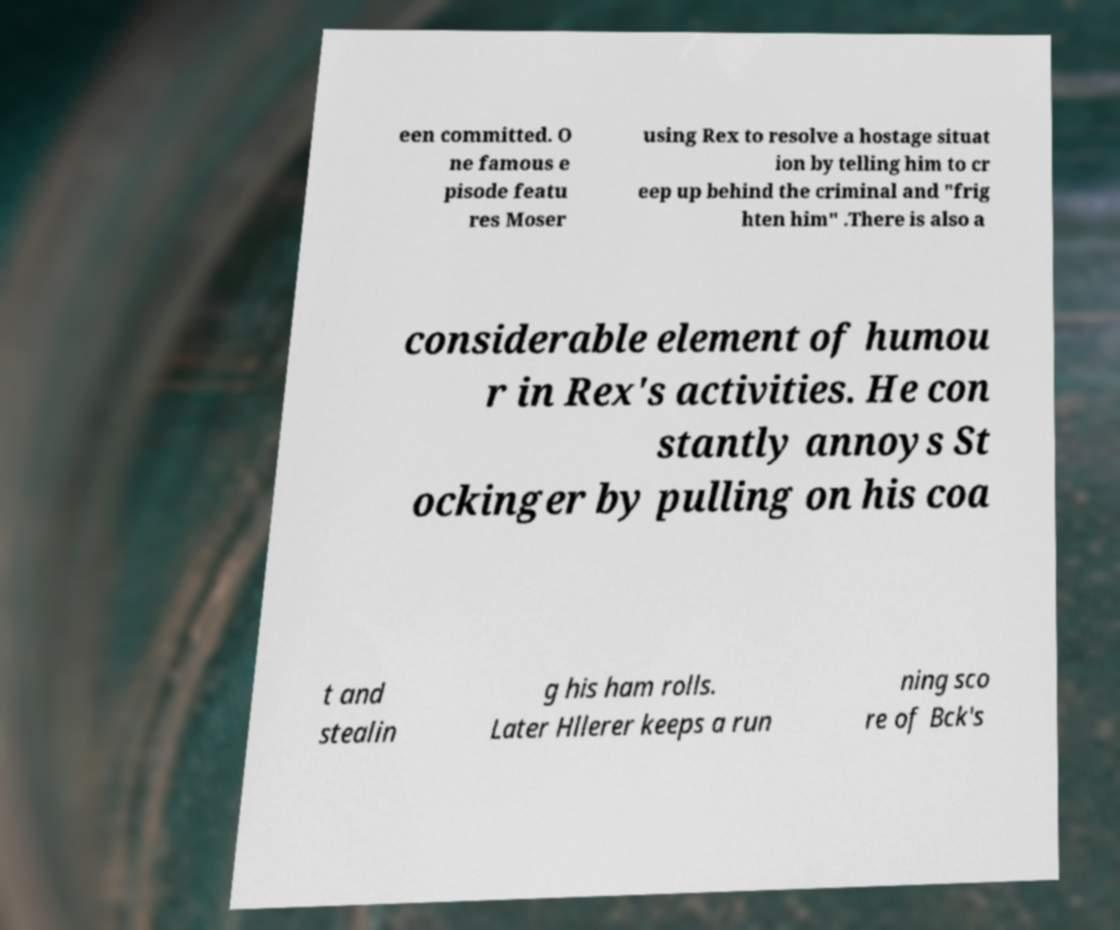Can you read and provide the text displayed in the image?This photo seems to have some interesting text. Can you extract and type it out for me? een committed. O ne famous e pisode featu res Moser using Rex to resolve a hostage situat ion by telling him to cr eep up behind the criminal and "frig hten him" .There is also a considerable element of humou r in Rex's activities. He con stantly annoys St ockinger by pulling on his coa t and stealin g his ham rolls. Later Hllerer keeps a run ning sco re of Bck's 